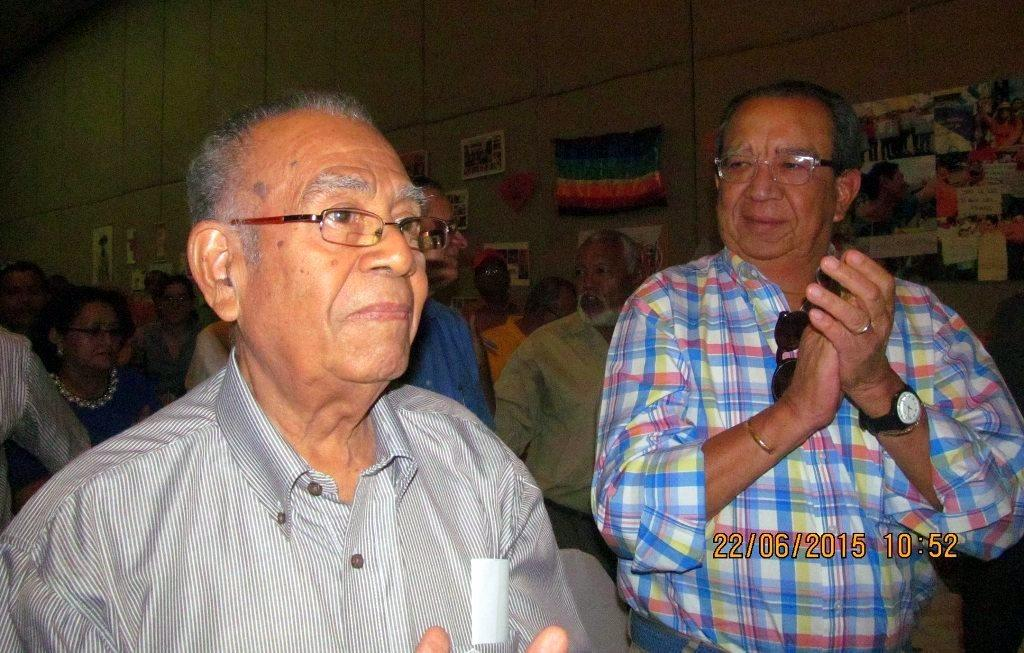How many men are present in the image? There are two men standing in the image. What can be seen in the background of the image? There is a group of people in the background of the image. What is located on the right side of the image? There are posts, flags, and a photo frame attached to a wall on the right side of the image. What type of bread is being served at the home in the image? There is no home or bread present in the image. What emotion are the men in the image experiencing? The image does not provide information about the emotions of the men, so it cannot be determined from the image. 